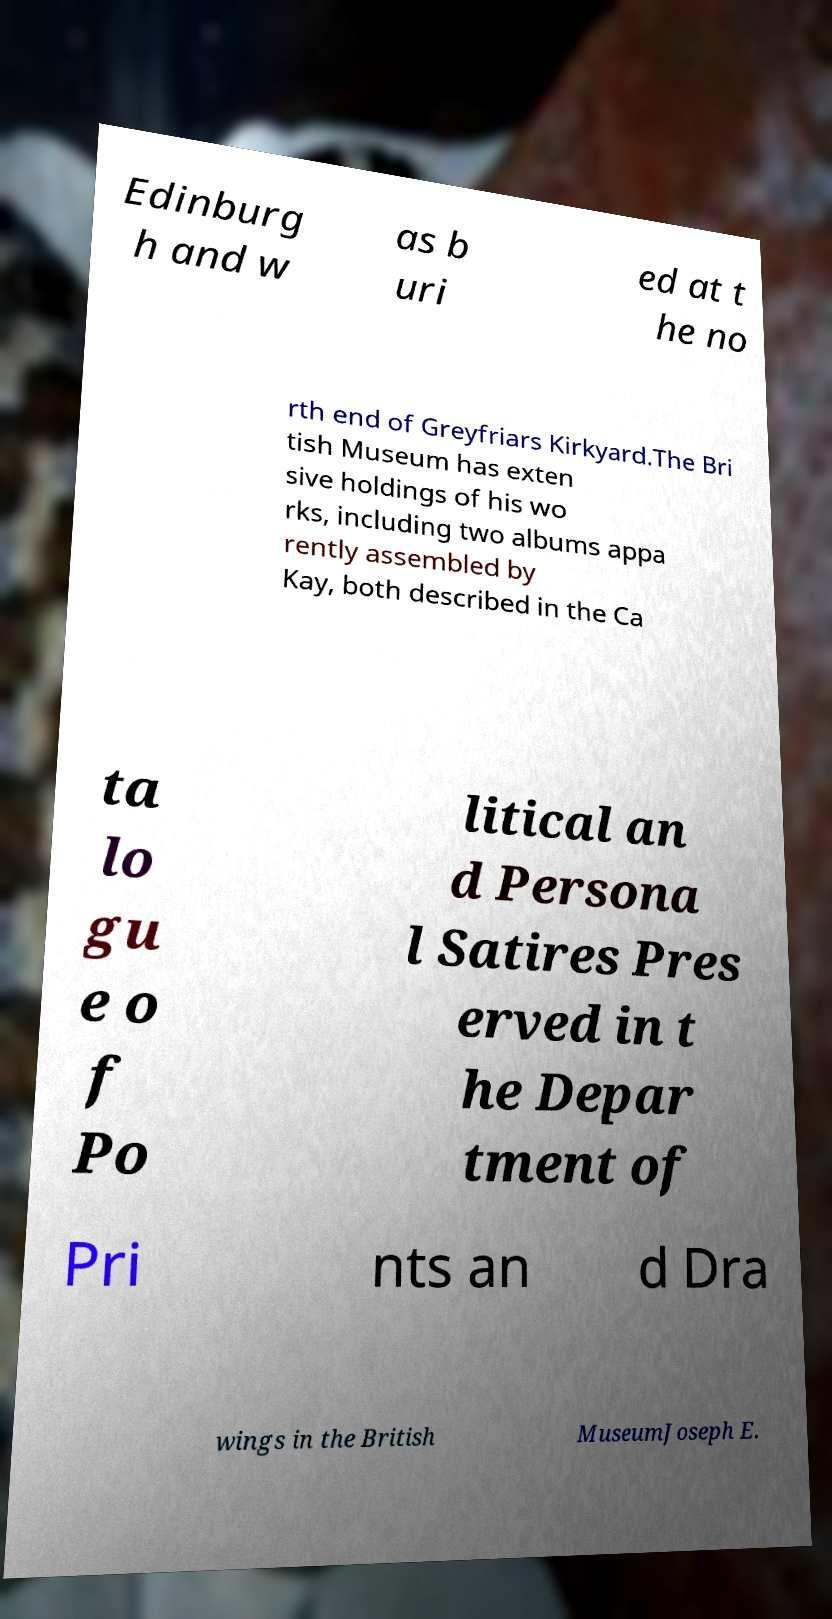Could you extract and type out the text from this image? Edinburg h and w as b uri ed at t he no rth end of Greyfriars Kirkyard.The Bri tish Museum has exten sive holdings of his wo rks, including two albums appa rently assembled by Kay, both described in the Ca ta lo gu e o f Po litical an d Persona l Satires Pres erved in t he Depar tment of Pri nts an d Dra wings in the British MuseumJoseph E. 